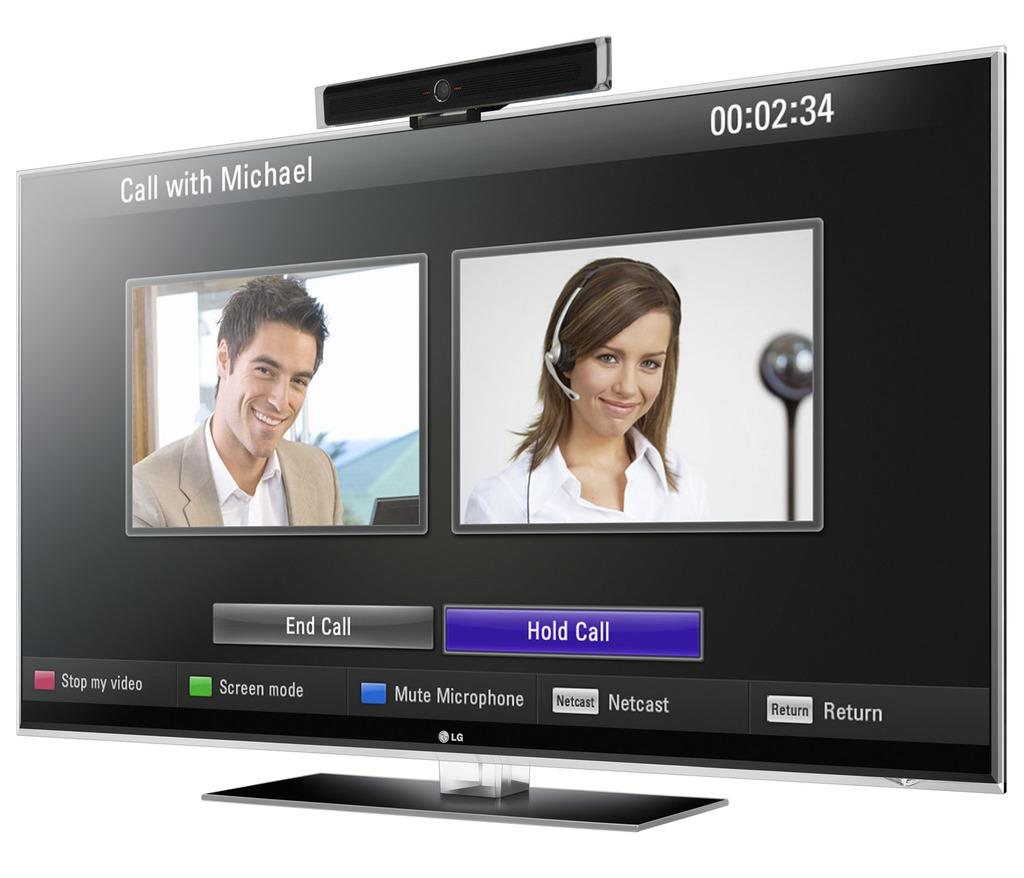<image>
Share a concise interpretation of the image provided. a hold call sign is under a lady 